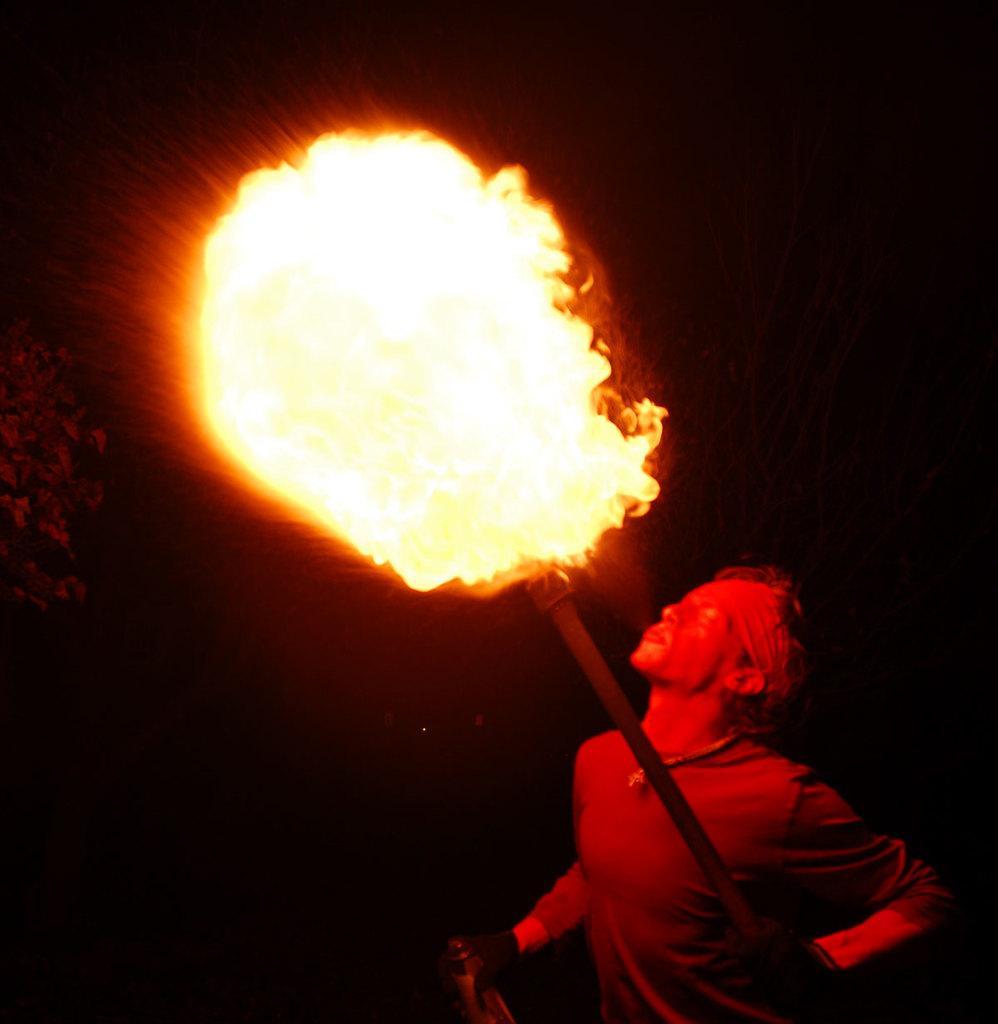How would you summarize this image in a sentence or two? In the picture we can see a man standing and holding a stick with a fire and blowing it in the dark. 